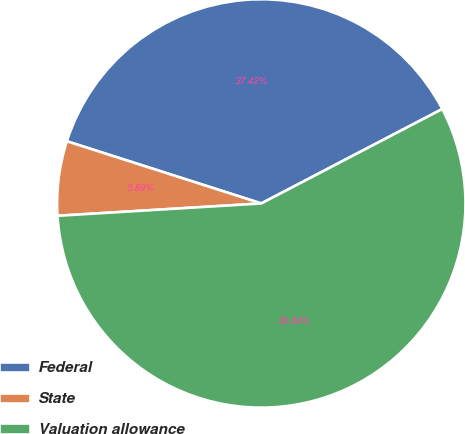Convert chart to OTSL. <chart><loc_0><loc_0><loc_500><loc_500><pie_chart><fcel>Federal<fcel>State<fcel>Valuation allowance<nl><fcel>37.42%<fcel>5.89%<fcel>56.69%<nl></chart> 